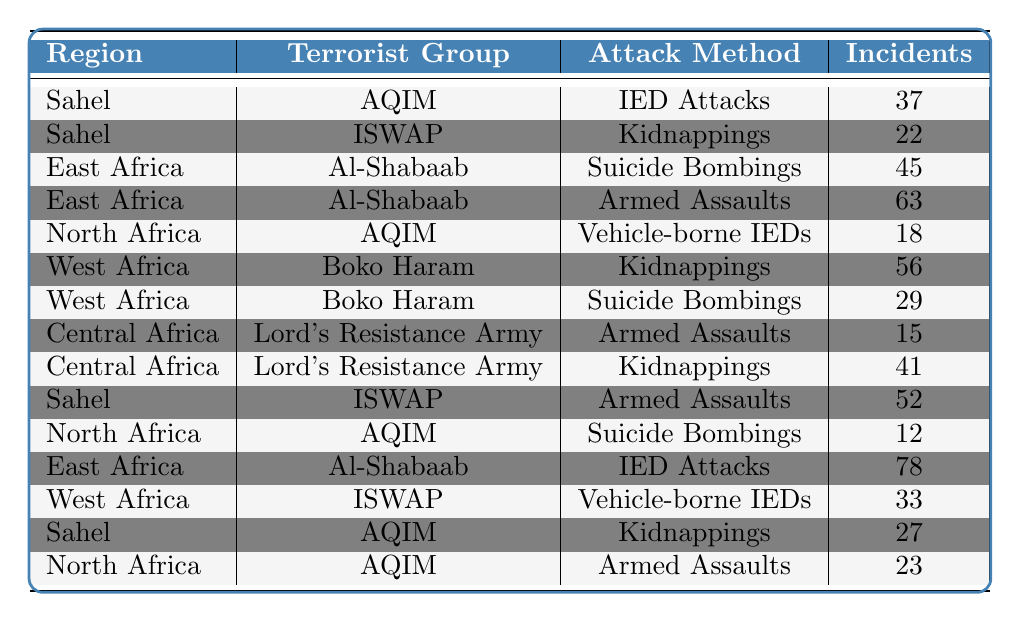What is the total number of incidents attributed to Al-Shabaab? Al-Shabaab has two entries: one with 45 incidents (Suicide Bombings) and another with 63 incidents (Armed Assaults). Summing these gives 45 + 63 = 108 incidents.
Answer: 108 Which region has the highest number of IED attacks? In East Africa, there are 78 incidents of IED Attacks attributed to Al-Shabaab. The only other IED Attack occurs in the Sahel with 37 incidents by AQIM. So, East Africa is the region with the highest number of IED attacks.
Answer: East Africa Is there a terrorist group in North Africa that uses armed assaults? There is an entry for AQIM in North Africa with 23 incidents of Armed Assaults. Therefore, there is a terrorist group that uses this method in North Africa.
Answer: Yes What method of attack does Boko Haram use the most in West Africa? Boko Haram has two entries in West Africa: 56 incidents (Kidnappings) and 29 incidents (Suicide Bombings). Since 56 > 29, Boko Haram uses Kidnappings the most in this region.
Answer: Kidnappings How many total incidents did ISWAP conduct across all regions? ISWAP has three entries: 22 incidents (Kidnappings) in the Sahel, 52 incidents (Armed Assaults) in the Sahel, and 33 incidents (Vehicle-borne IEDs) in West Africa. Summing these yields 22 + 52 + 33 = 107 incidents.
Answer: 107 Which attack method has the highest incidents in the Sahel region? In the Sahel, there are three entries: AQIM with 37 (IED Attacks), ISWAP with 22 (Kidnappings), and ISWAP with 52 (Armed Assaults). Since 52 is the highest value, Armed Assaults are the most prevalent attack method in this region.
Answer: Armed Assaults What is the combined number of Kidnappings by Lord’s Resistance Army? Lord's Resistance Army has two entries: 41 incidents (Kidnappings) in Central Africa. Thus, the total number of Kidnappings by this group is 41.
Answer: 41 Which region has the least number of total incidents for AQIM? AQIM has three entries: 37 incidents (IED Attacks) in Sahel, 18 incidents (Vehicle-borne IEDs) in North Africa, and 12 incidents (Suicide Bombings) in North Africa. The least is 12 incidents in North Africa.
Answer: North Africa How many more incidents of Armed Assaults does Al-Shabaab have compared to Lord's Resistance Army? Al-Shabaab has 63 (Armed Assaults) in East Africa while Lord's Resistance Army has 15 (Armed Assaults) in Central Africa. The difference is 63 - 15 = 48 incidents.
Answer: 48 Which terrorist group has conducted the highest number of incidents in Central Africa? Lord's Resistance Army has two entries in Central Africa: 15 incidents (Armed Assaults) and 41 incidents (Kidnappings). The total for Lord's Resistance Army is 15 + 41 = 56 incidents, thus making it the group with the highest incidents in Central Africa.
Answer: Lord's Resistance Army 